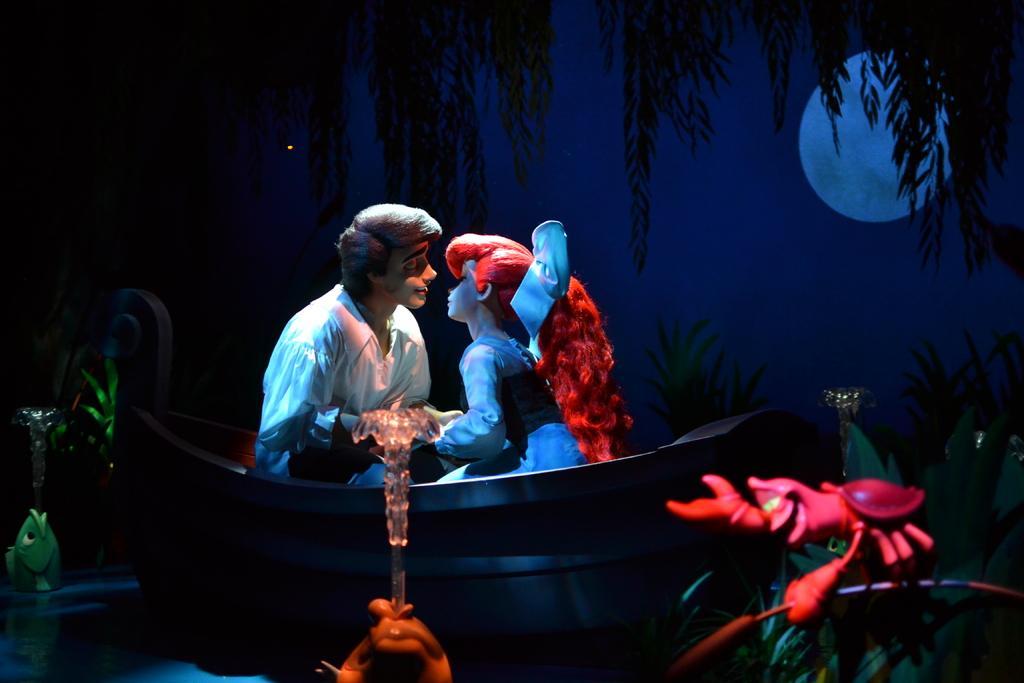Can you describe this image briefly? In the image we can see an animated picture of two people sitting and wearing clothes. Here we can see the water, trees, moon and the sky. 